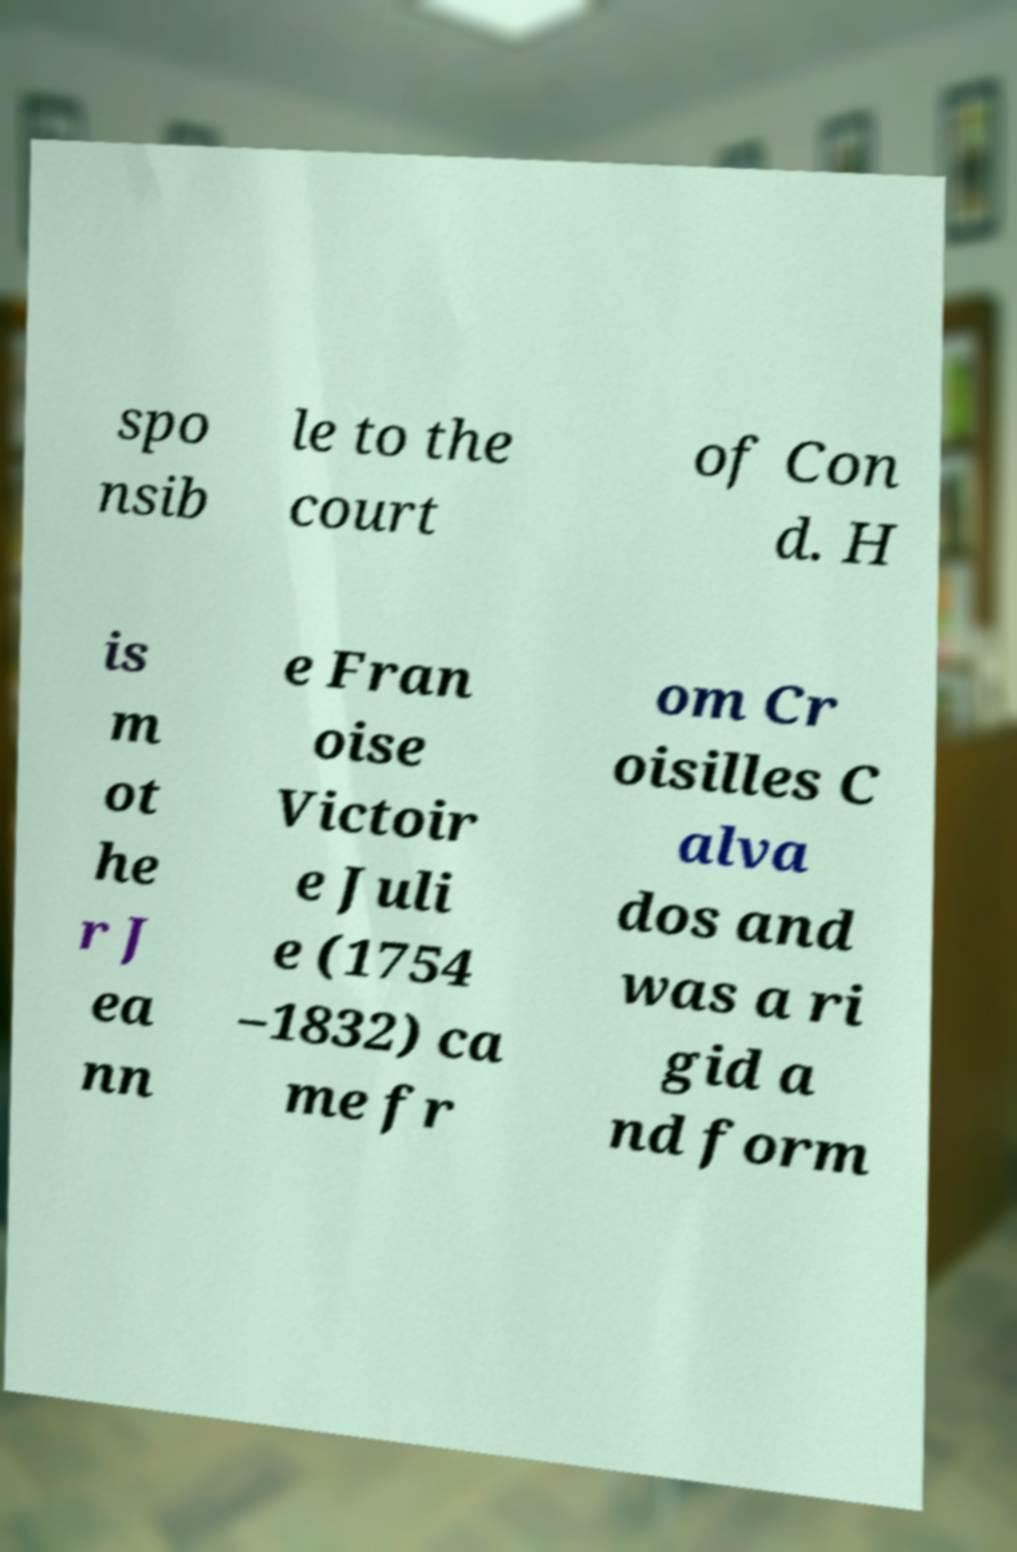Please read and relay the text visible in this image. What does it say? spo nsib le to the court of Con d. H is m ot he r J ea nn e Fran oise Victoir e Juli e (1754 –1832) ca me fr om Cr oisilles C alva dos and was a ri gid a nd form 